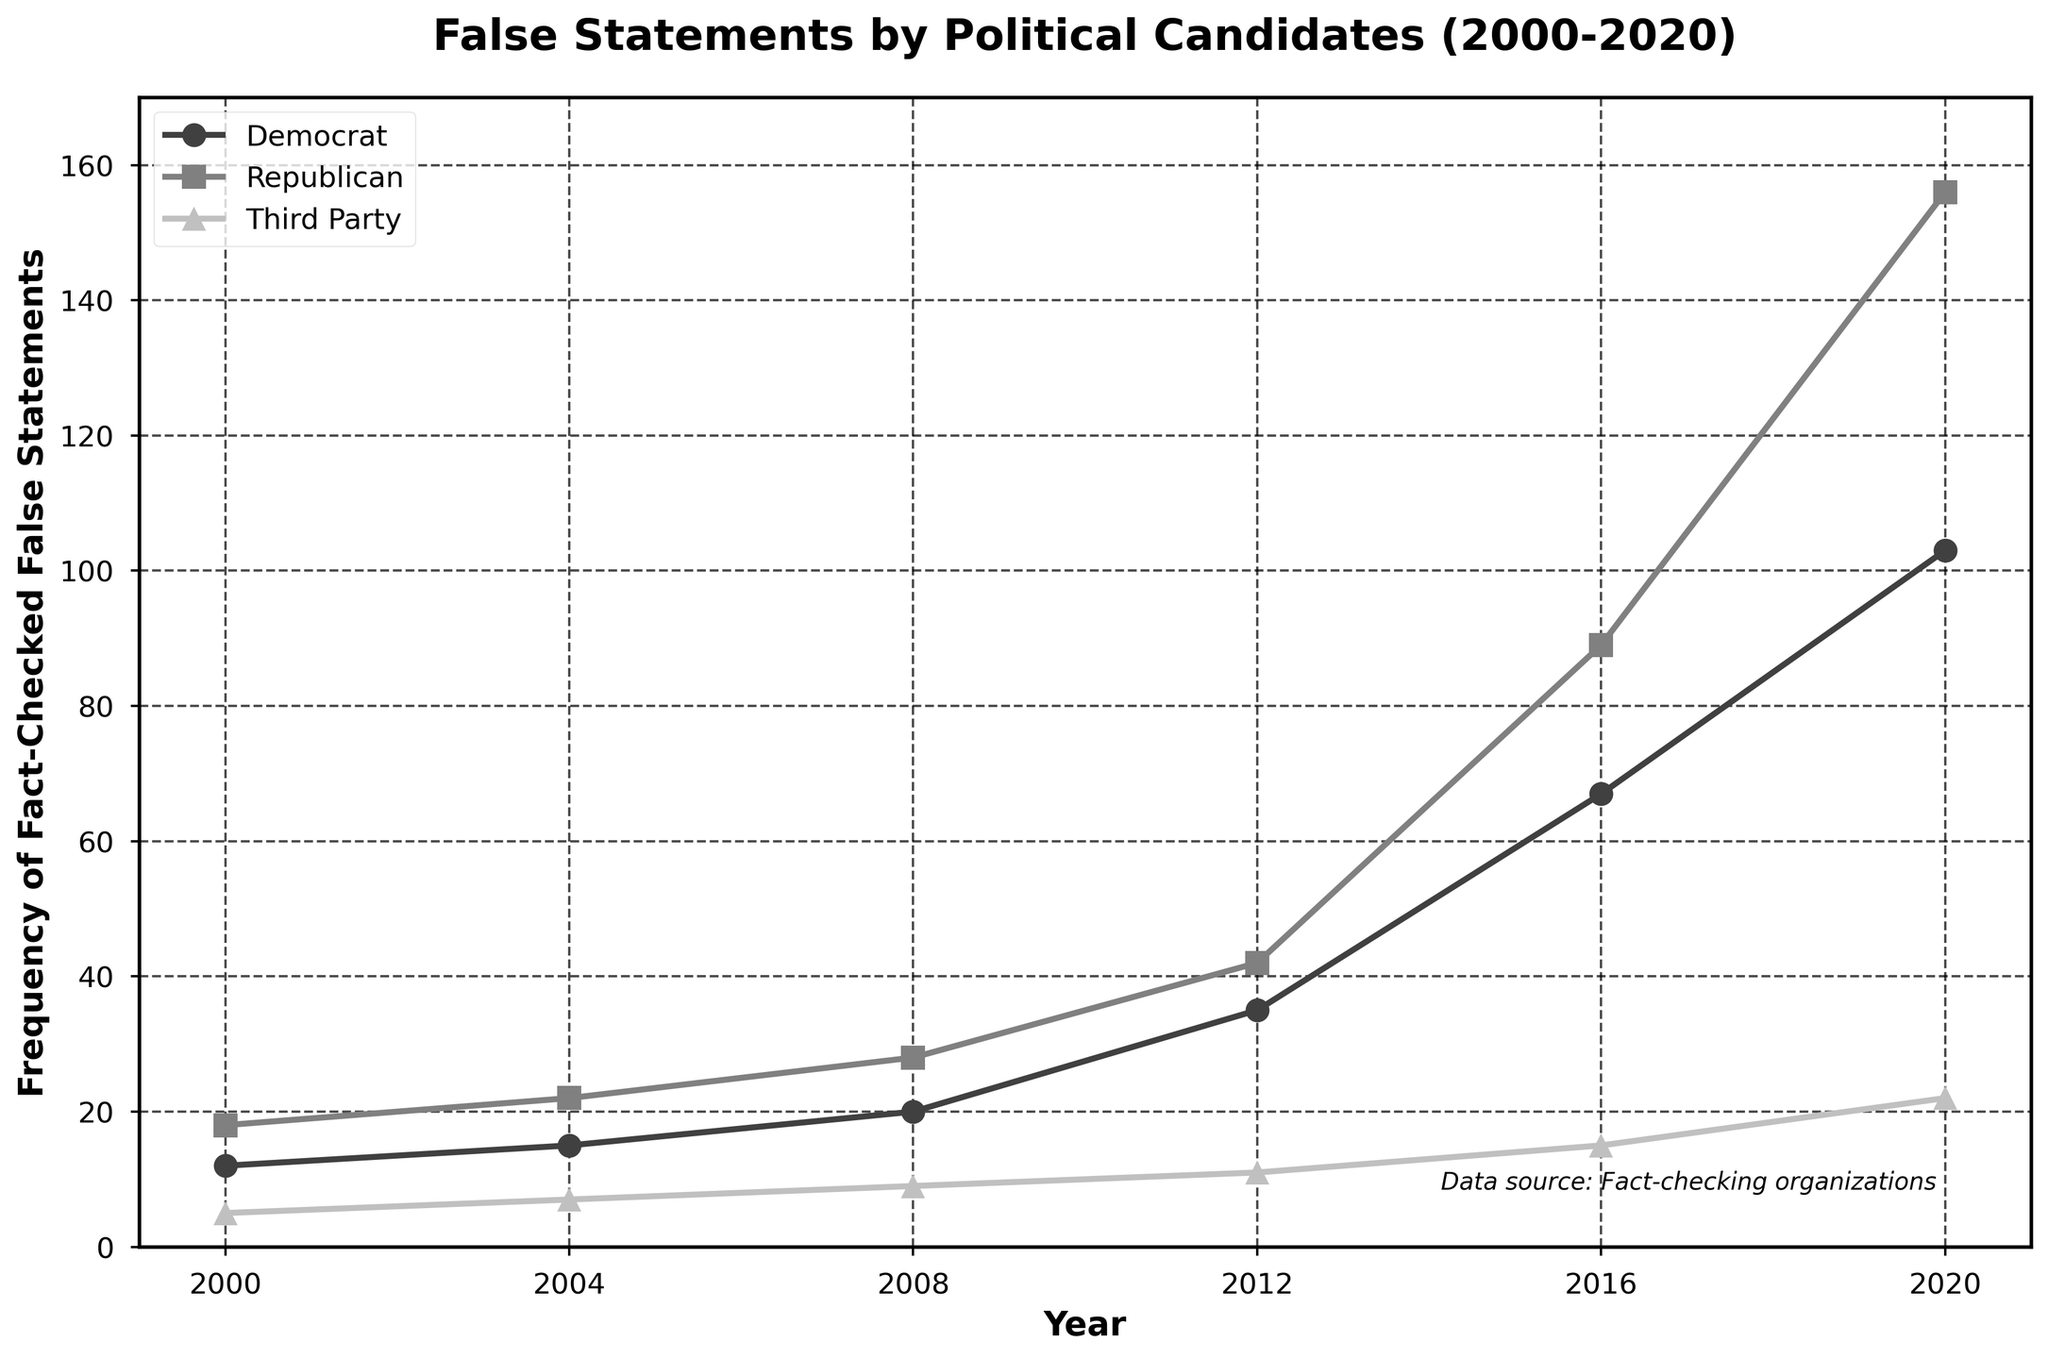What year shows the highest frequency of false statements for Democrats? To find the year with the highest frequency of false statements for Democrats, look at the curve representing Democrats and identify the peak. The highest point on this curve corresponds to the year 2020.
Answer: 2020 Compare the frequency of false statements made by Republicans in 2008 to that of Democrats in 2016. Which is higher? Locate the values for Republicans in 2008 and Democrats in 2016 on their respective curves. Republicans in 2008 made 28 false statements, while Democrats in 2016 made 67. Therefore, Democrats in 2016 made more false statements.
Answer: Democrats in 2016 What is the total number of fact-checked false statements made by Third Party candidates across all years? Add the number of false statements made by Third Party candidates in each year: 5 + 7 + 9 + 11 + 15 + 22. The result is the total frequency.
Answer: 69 What is the average number of false statements made by Republicans during the 2000-2020 period? To calculate the average, sum the values for Republicans across all years: 18 + 22 + 28 + 42 + 89 + 156. Then divide by the number of data points, which is 6.
Answer: 59.17 In which years did the frequency of false statements for all three groups increase compared to the previous election cycle? Identify the years where the frequency for all three groups increased compared to the previous year. Such increases are observed from 2004 (compared to 2000), 2008 (compared to 2004), 2012 (compared to 2008), 2016 (compared to 2012), and 2020 (compared to 2016).
Answer: 2004, 2008, 2012, 2016, 2020 How much higher were the false statements made by Republicans compared to Third Party candidates in 2020? Subtract the number of false statements made by Third Party candidates from the number made by Republicans in 2020: 156 - 22.
Answer: 134 Between which consecutive election years did Democrats see the largest increase in false statements? Calculate the difference in false statements between consecutive years for Democrats: (2004-2000), (2008-2004), (2012-2008), (2016-2012), (2020-2016). The largest increment is the highest value out of these calculations.
Answer: 2020-2016 How many more false statements did Republicans make than Democrats in 2012? Subtract the number of false statements made by Democrats from the number made by Republicans in 2012: 42 - 35.
Answer: 7 What is the visual trend of false statements made by political candidates from 2000 to 2020? Examining the overall trend for each group on the graph visually, all three groups show an increasing trend in the frequency of false statements over time.
Answer: Increasing In which year did all three groups have the closest values of false statements? Compare the values across different years to find the year where the false statements were most similar for Democrats, Republicans, and Third Party candidates. The year with the smallest range between the highest and lowest values is 2000.
Answer: 2000 